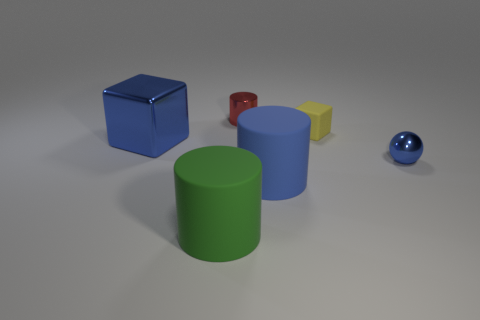Add 1 tiny blue metal balls. How many objects exist? 7 Subtract all blocks. How many objects are left? 4 Add 3 blue rubber cylinders. How many blue rubber cylinders are left? 4 Add 2 big blue rubber cylinders. How many big blue rubber cylinders exist? 3 Subtract 0 brown blocks. How many objects are left? 6 Subtract all red things. Subtract all big brown things. How many objects are left? 5 